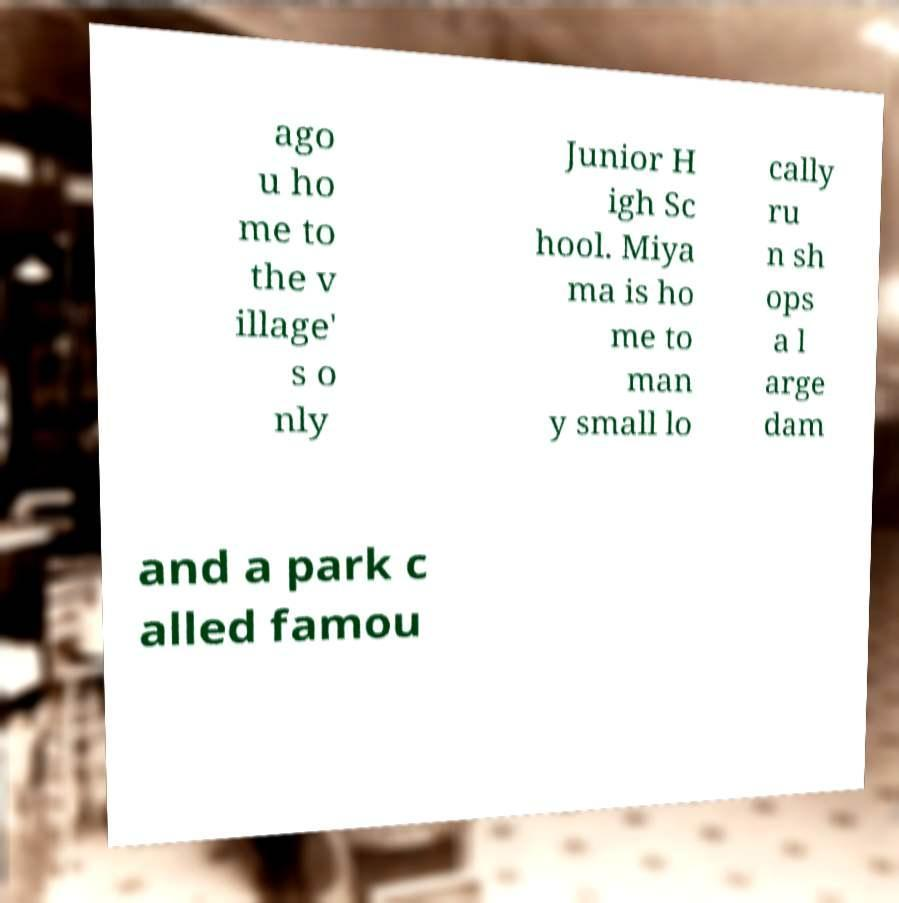Please identify and transcribe the text found in this image. ago u ho me to the v illage' s o nly Junior H igh Sc hool. Miya ma is ho me to man y small lo cally ru n sh ops a l arge dam and a park c alled famou 